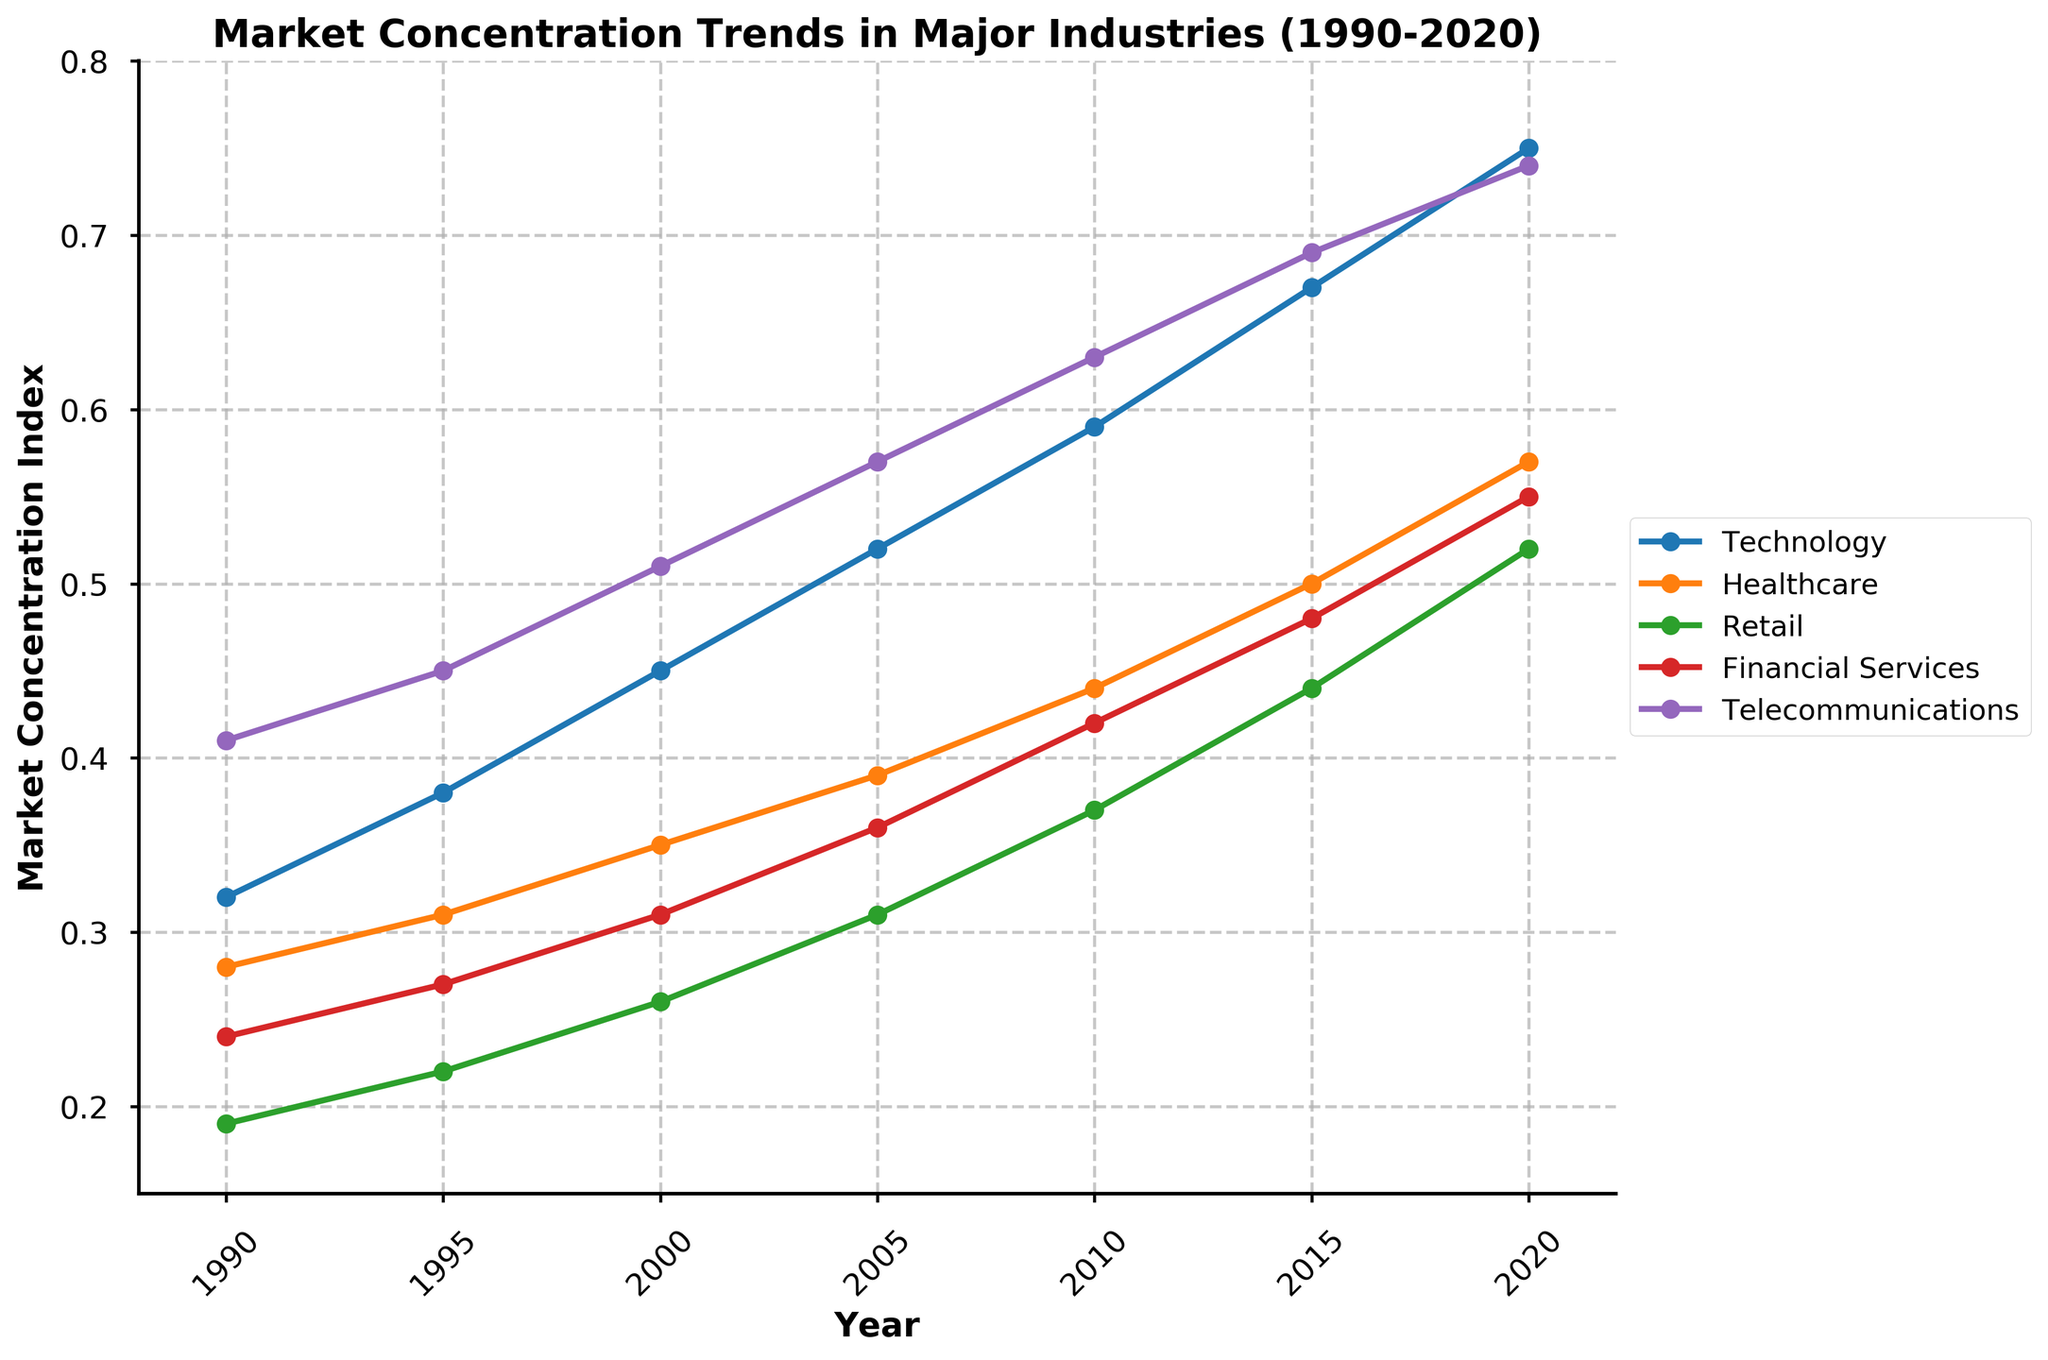what is the trend of market concentration in the Technology industry from 1990 to 2020? Observing the Technology industry's line in the chart, it continuously increases from 0.32 in 1990 to 0.75 in 2020.
Answer: Increasing Which industry had the highest market concentration in 2010? In 2010, the Telecommunications industry had the highest market concentration with a value of 0.63, as seen from the highest point on the y-axis for that year.
Answer: Telecommunications How does the market concentration in Healthcare in 2005 compare to that in 2020? In 2005, Healthcare had a market concentration of 0.39, whereas in 2020, it increased to 0.57. Thus, there is a significant increase.
Answer: Increased Which industry's market concentration grew the most from 1990 to 2020? By calculating the difference for each industry from 1990 to 2020: Technology (0.75-0.32), Healthcare (0.57-0.28), Retail (0.52-0.19), Financial Services (0.55-0.24), Telecommunications (0.74-0.41), Technology sees the largest increase of 0.43.
Answer: Technology What were the market concentration values for Retail and Financial Services in 2000, and which was higher? In 2000, Retail had a market concentration of 0.26, and Financial Services had 0.31; thus, Financial Services was higher.
Answer: Financial Services Comparing Retail and Technology in 2015, which shows a higher rate of increase from 1990? For 2015, Retail increased from 0.19 in 1990 to 0.44; an increase of 0.25, and Technology increased from 0.32 to 0.67; an increase of 0.35. Thus, Technology had a higher rate of increase.
Answer: Technology What is the average market concentration for Financial Services over the 30 years? Adding up the Financial Services values from 1990 to 2020: (0.24 + 0.27 + 0.31 + 0.36 + 0.42 + 0.48 + 0.55) = 2.63, and dividing by 7 years, the average is 2.63 / 7 = 0.376
Answer: 0.376 In which year did the Telecommunications industry surpass a market concentration index of 0.5? Observing the trend in Telecommunications, it surpasses 0.5 in the year 2000, reaching exactly 0.51.
Answer: 2000 